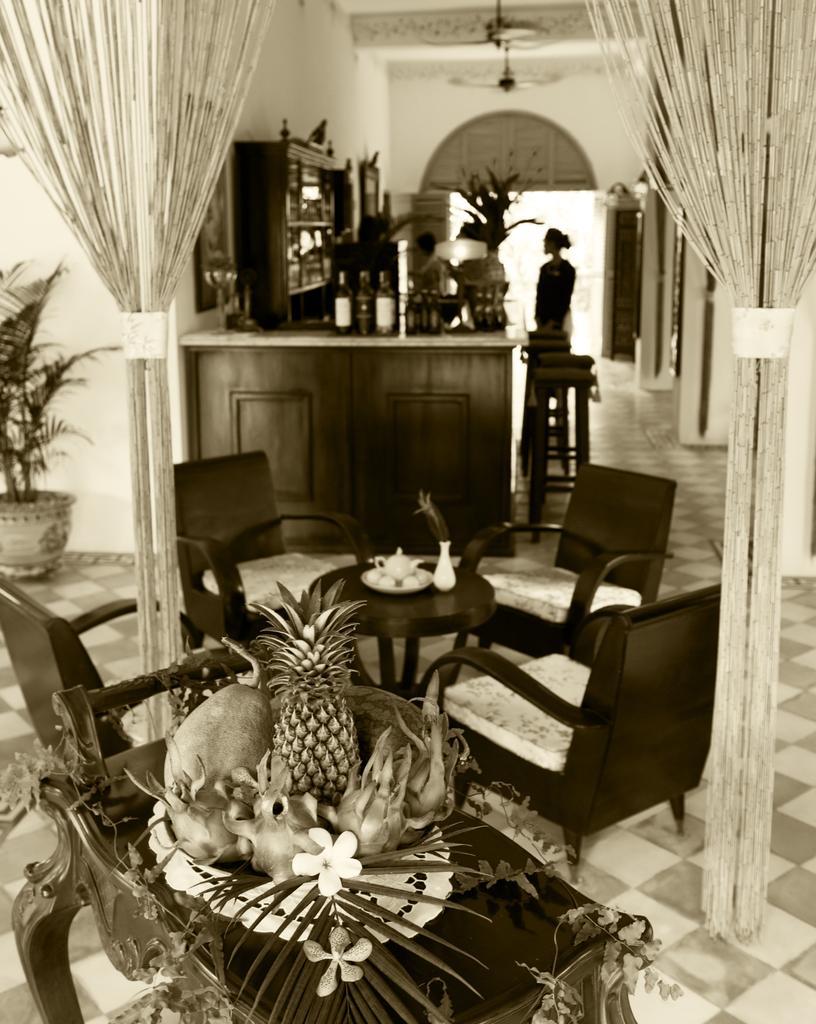Please provide a concise description of this image. There is a table. On this table there are flowers, leaf, fruits, pineapple. There are chairs. There is another table. On this table, there is plate and jars. And in the background there is a pot with plant. There are curtains. And also there is a cupboard. On this there are bottles. A person is standing in the background. 